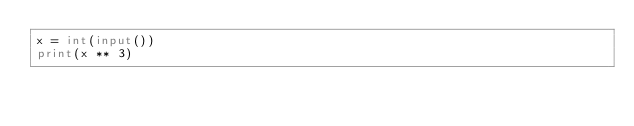<code> <loc_0><loc_0><loc_500><loc_500><_Python_>x = int(input())
print(x ** 3)
</code> 